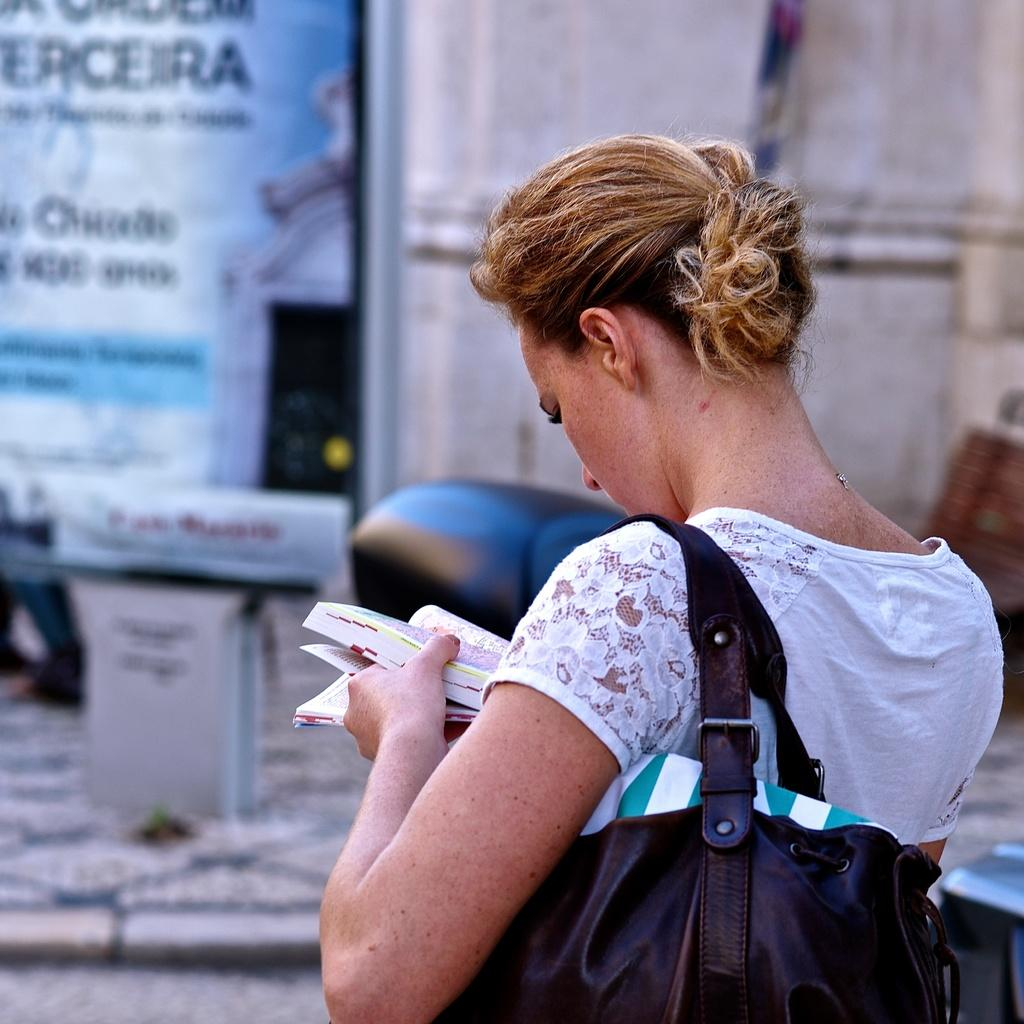What is the woman in the image holding in her hand? The woman is holding a handbag and a book in the image. What type of clothing is the woman wearing on her upper body? The woman is wearing a white t-shirt in the image. What color is the suit the woman is wearing in the image? There is no suit present in the image; the woman is wearing a white t-shirt. How many pockets can be seen on the handbag the woman is holding in the image? The provided facts do not mention the number of pockets on the handbag, so it cannot be determined from the image. 